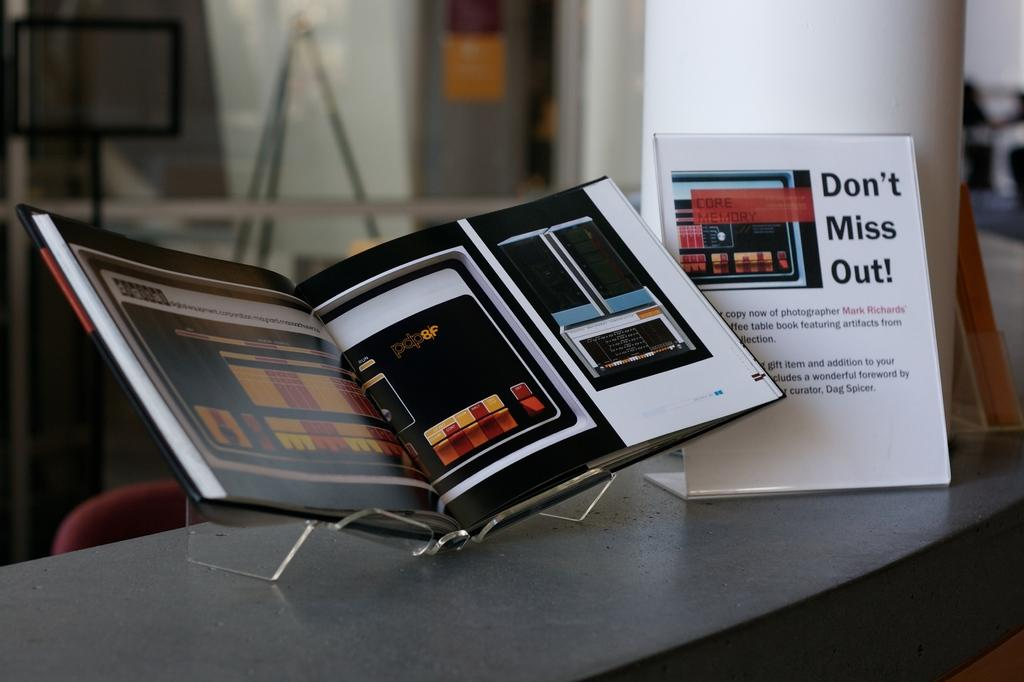<image>
Render a clear and concise summary of the photo. Paper advertisements for an unknown product that reads "Don't Miss Out!" 